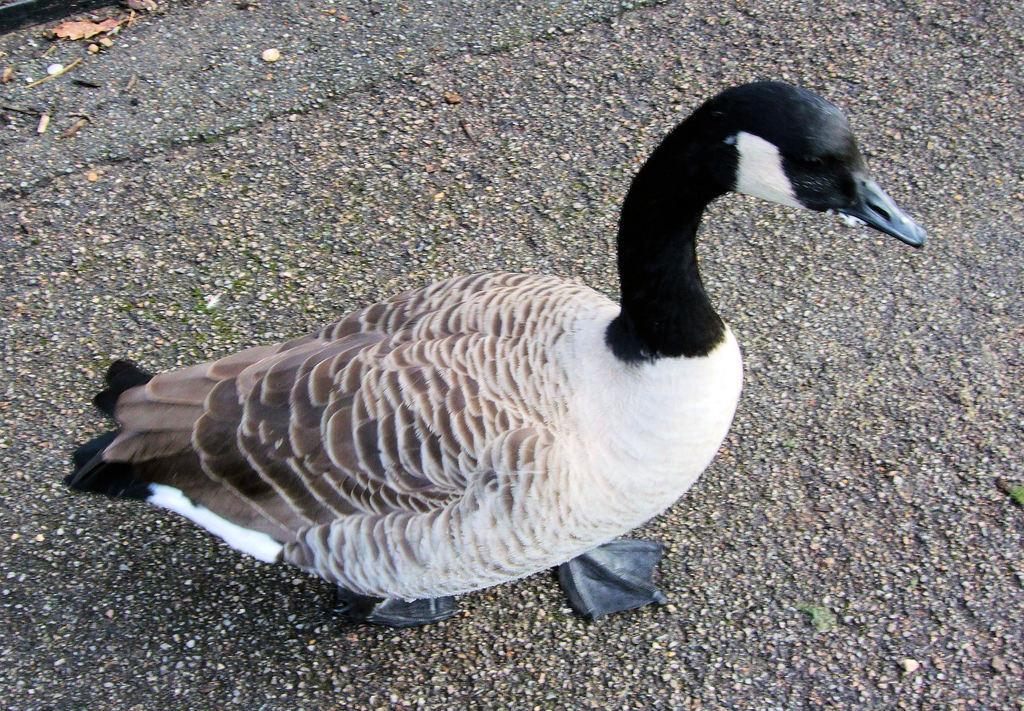Can you describe this image briefly? In this picture I can see a duck. It is white black and brown in color. 